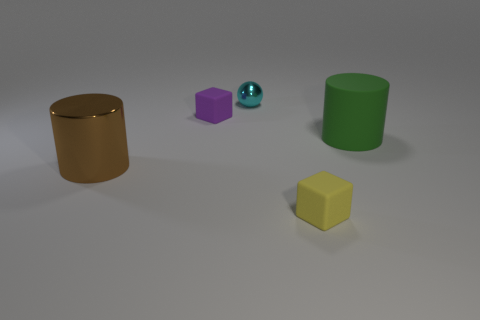Add 5 big green rubber objects. How many objects exist? 10 Subtract all cylinders. How many objects are left? 3 Subtract all brown cylinders. Subtract all yellow matte objects. How many objects are left? 3 Add 3 small purple matte objects. How many small purple matte objects are left? 4 Add 1 small yellow matte objects. How many small yellow matte objects exist? 2 Subtract 0 cyan cylinders. How many objects are left? 5 